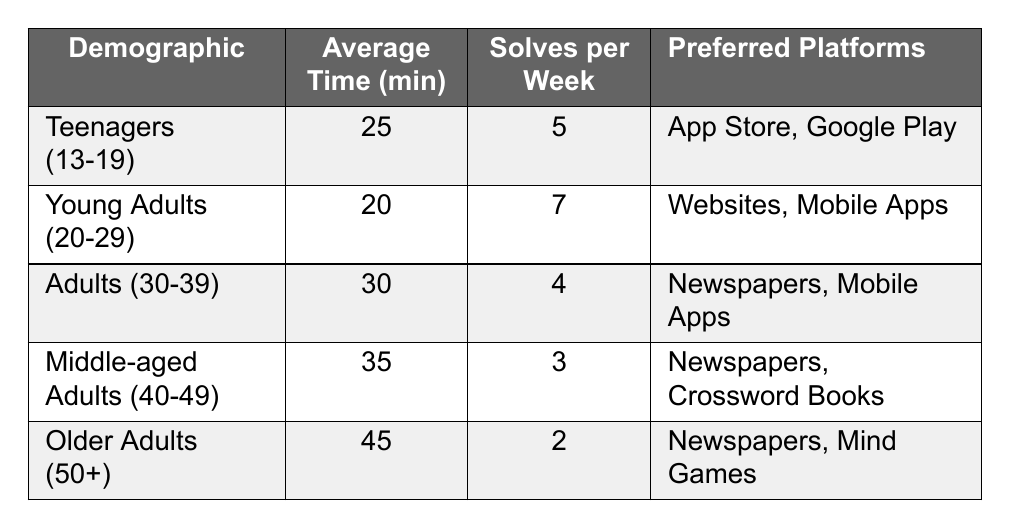What is the average solving time for Young Adults (20-29)? The table shows that the average solving time for Young Adults (20-29) is listed in the "Average Time (min)" column, which states 20 minutes.
Answer: 20 minutes How many solves per week do Middle-aged Adults (40-49) typically complete? In the table, the "Solves per Week" column for Middle-aged Adults (40-49) states they complete 3 crossword puzzles weekly.
Answer: 3 Which demographic spends the most time solving crossword puzzles on average? By comparing the "Average Time (min)" column, Older Adults (50+) have the highest average time, which is 45 minutes.
Answer: Older Adults (50+) Are there any demographics that prefer "Mobile Apps" as a platform for crossword solving? The table indicates that both Young Adults (20-29) and Adults (30-39) mention "Mobile Apps" among their preferred platforms. Thus, the answer is yes.
Answer: Yes What is the difference in average solving time between Teenagers (13-19) and Older Adults (50+)? The average time for Teenagers (13-19) is 25 minutes, and for Older Adults (50+) it is 45 minutes. The difference is 45 - 25 = 20 minutes.
Answer: 20 minutes What is the average number of solves per week across all demographics? To find this, sum the "Solves per Week" values: 5 + 7 + 4 + 3 + 2 = 21. Then divide by the number of demographics (5). The average is 21 / 5 = 4.2.
Answer: 4.2 Do Adults (30-39) solve more puzzles per week than Middle-aged Adults (40-49)? The table states that Adults (30-39) solve 4 puzzles per week while Middle-aged Adults (40-49) solve 3. Since 4 is greater than 3, the answer is yes.
Answer: Yes What are the preferred platforms for the demographic that takes the longest time to solve crosswords? The demographic taking the longest time is Older Adults (50+), and their preferred platforms are listed as "Newspapers" and "Mind Games."
Answer: Newspapers, Mind Games How many more minutes do Middle-aged Adults (40-49) spend on average compared to Young Adults (20-29)? Middle-aged Adults (40-49) have an average time of 35 minutes, while Young Adults (20-29) have an average of 20 minutes. The difference is 35 - 20 = 15 minutes more.
Answer: 15 minutes Which demographic solves the highest number of crossword puzzles per week? By looking at the "Solves per Week" column, Young Adults (20-29) solve the highest number, which is 7 puzzles per week.
Answer: Young Adults (20-29) Is the average solving time for Adults (30-39) less than the average solving time for Teenagers (13-19)? The average time for Adults (30-39) is 30 minutes, and for Teenagers (13-19) it is 25 minutes. Since 30 is not less than 25, the answer is no.
Answer: No 